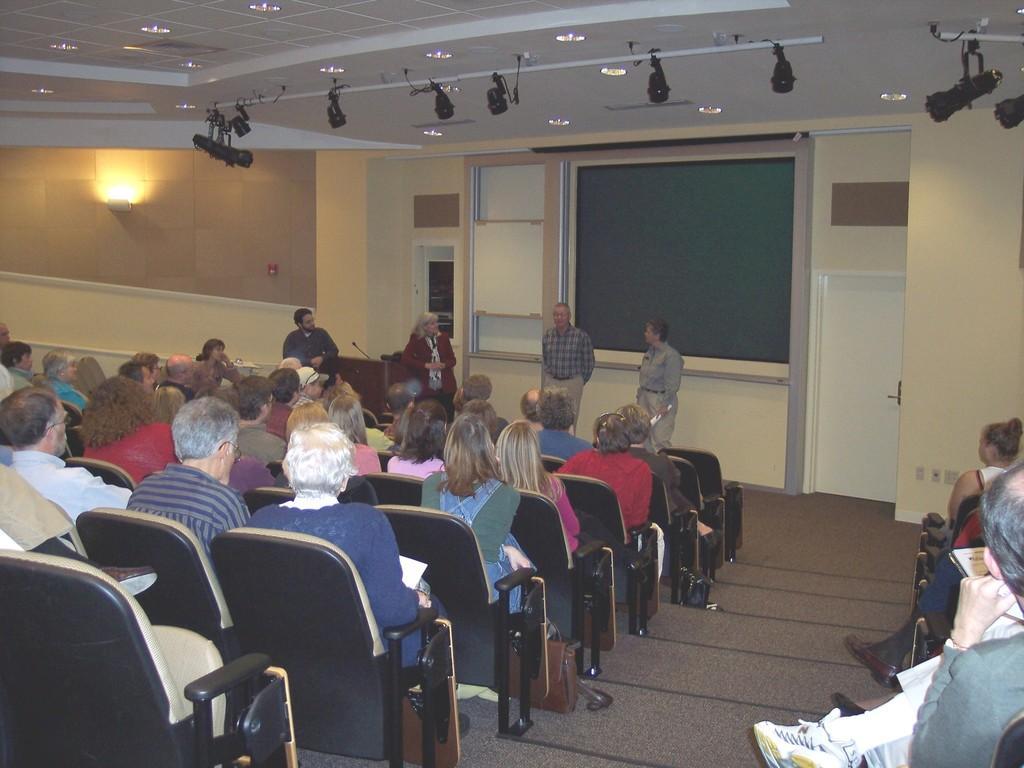Describe this image in one or two sentences. In the image we can see there are lot of people who are sitting on chair and in front of them there are people who are standing. 